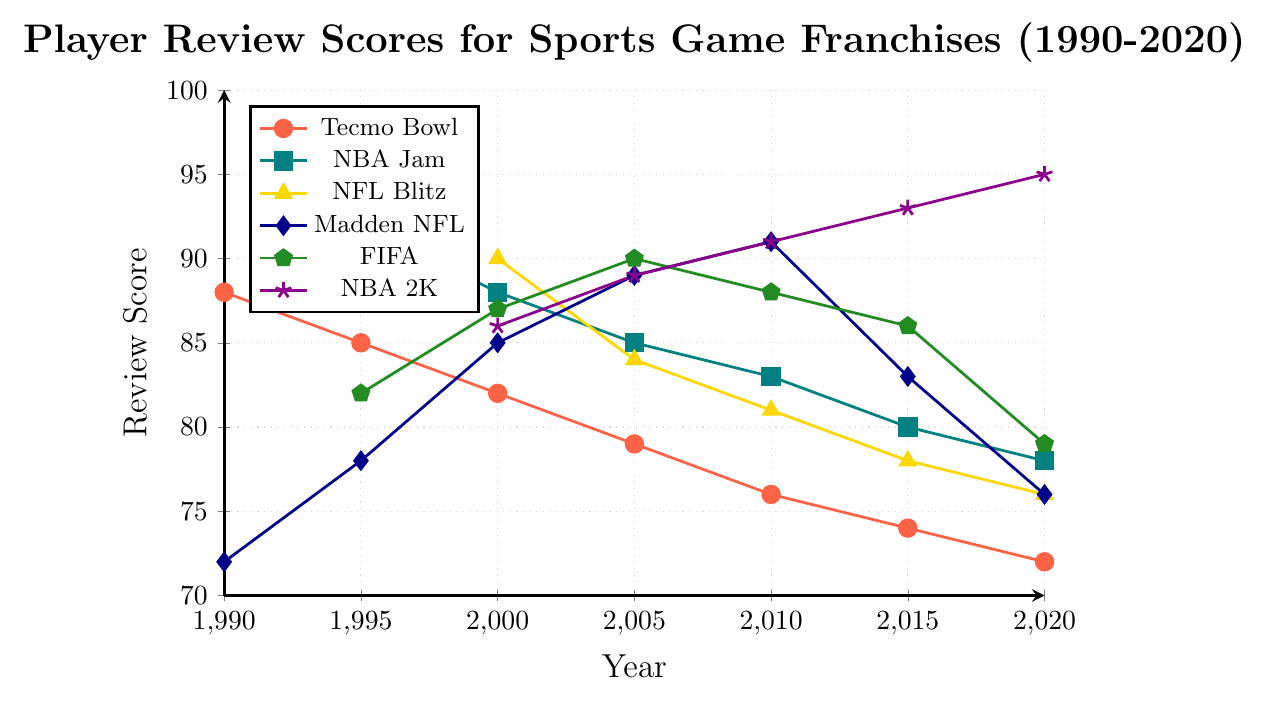Which franchise had the highest player review score in 2000? According to the figure, NFL Blitz had the highest player review score in 2000, with a score of 90.
Answer: NFL Blitz Which arcade-style title saw the greatest decline in player review scores from 2000 to 2020? To find the difference, we need to subtract the 2020 score from the 2000 score for each arcade-style title. Tecmo Bowl's decline: 82 - 72 = 10 points, NBA Jam's decline: 88 - 78 = 10 points, NFL Blitz's decline: 90 - 76 = 14 points. Thus, NFL Blitz experienced the greatest decline of 14 points.
Answer: NFL Blitz How do the review scores of Madden NFL and NBA 2K compare in 2020? In 2020, the player review score for Madden NFL is 76 while for NBA 2K it is 95, making NBA 2K the higher scoring game.
Answer: NBA 2K is higher What is the average player review score for NBA Jam from 1995 to 2020? Add up the scores from 1995 to 2020: 92 + 88 + 85 + 83 + 80 + 78 = 506. Divide by the number of years: 506 / 6 = 84.33.
Answer: 84.33 Which franchise showed the least decline in player review scores from their highest rating to 2020? By comparing the highest scores for each franchise to their 2020 scores, we calculate the declines: Tecmo Bowl (88 to 72, decline of 16), NBA Jam (92 to 78, decline of 14), NFL Blitz (90 to 76, decline of 14), Madden NFL (91 to 76, decline of 15), FIFA (90 to 79, decline of 11), NBA 2K (95 to 95, no decline). Hence, NBA 2K showed the least decline with no loss at all.
Answer: NBA 2K In which year did FIFA reach its peak review score? By examining the review scores for FIFA across the years, the highest score is 90 in 2005.
Answer: 2005 How does the trend of arcade-style titles' scores compare to simulation-style titles from 1990 to 2020? Arcade-style titles (Tecmo Bowl, NBA Jam, NFL Blitz) generally show a downward trend over the years. In contrast, simulation-style titles (Madden NFL, FIFA, NBA 2K) initially rise, with NBA 2K continuing to rise till 2020, while Madden NFL and FIFA decline after peaking.
Answer: Arcade-style trends downward, Simulation-style mixed trends 